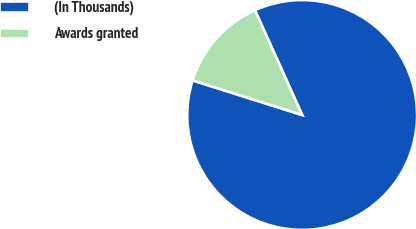<chart> <loc_0><loc_0><loc_500><loc_500><pie_chart><fcel>(In Thousands)<fcel>Awards granted<nl><fcel>86.61%<fcel>13.39%<nl></chart> 